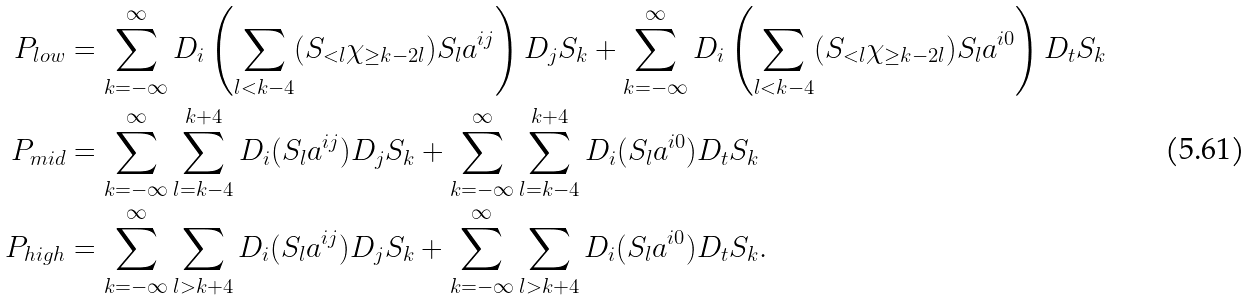Convert formula to latex. <formula><loc_0><loc_0><loc_500><loc_500>P _ { l o w } & = \sum _ { k = - \infty } ^ { \infty } D _ { i } \left ( \sum _ { l < k - 4 } ( S _ { < l } \chi _ { \geq k - 2 l } ) S _ { l } a ^ { i j } \right ) D _ { j } S _ { k } + \sum _ { k = - \infty } ^ { \infty } D _ { i } \left ( \sum _ { l < k - 4 } ( S _ { < l } \chi _ { \geq k - 2 l } ) S _ { l } a ^ { i 0 } \right ) D _ { t } S _ { k } \\ P _ { m i d } & = \sum _ { k = - \infty } ^ { \infty } \sum _ { l = k - 4 } ^ { k + 4 } D _ { i } ( S _ { l } a ^ { i j } ) D _ { j } S _ { k } + \sum _ { k = - \infty } ^ { \infty } \sum _ { l = k - 4 } ^ { k + 4 } D _ { i } ( S _ { l } a ^ { i 0 } ) D _ { t } S _ { k } \\ P _ { h i g h } & = \sum _ { k = - \infty } ^ { \infty } \sum _ { l > k + 4 } D _ { i } ( S _ { l } a ^ { i j } ) D _ { j } S _ { k } + \sum _ { k = - \infty } ^ { \infty } \sum _ { l > k + 4 } D _ { i } ( S _ { l } a ^ { i 0 } ) D _ { t } S _ { k } .</formula> 